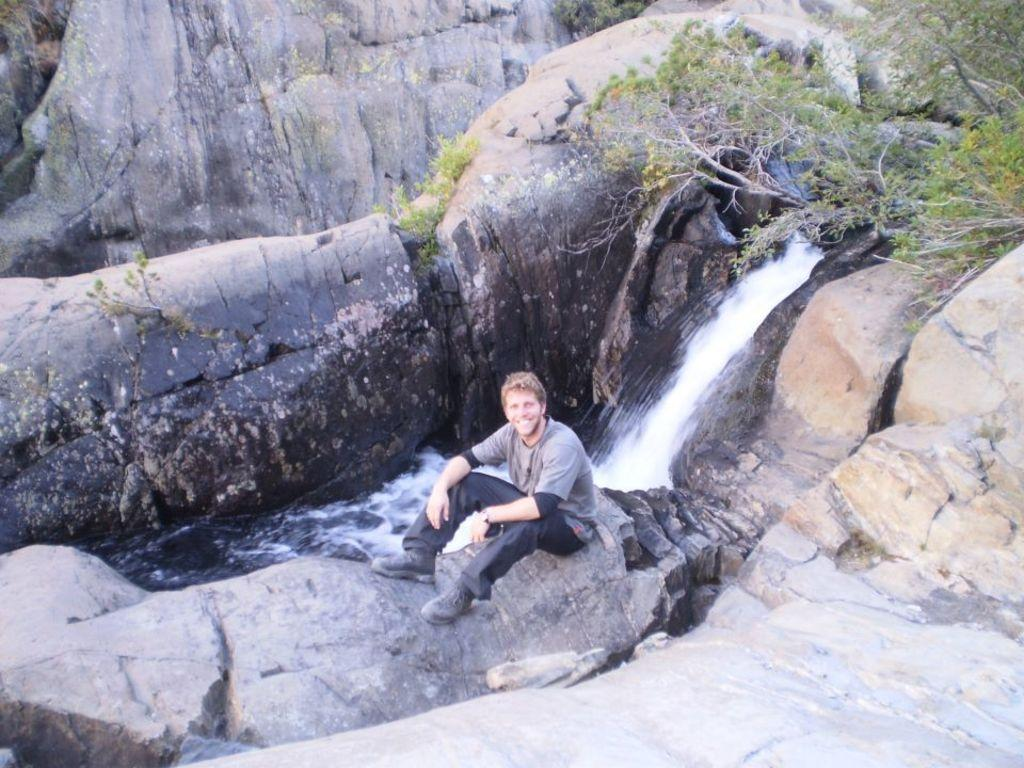What is the man in the image doing? The man is sitting on a rock in the image. What natural feature is located in the middle of the image? There is a waterfall in the middle of the image. What type of vegetation is on the right side of the image? There are trees on the right side of the image. What type of news can be heard coming from the waterfall in the image? There is no indication in the image that the waterfall is producing or transmitting any news. 